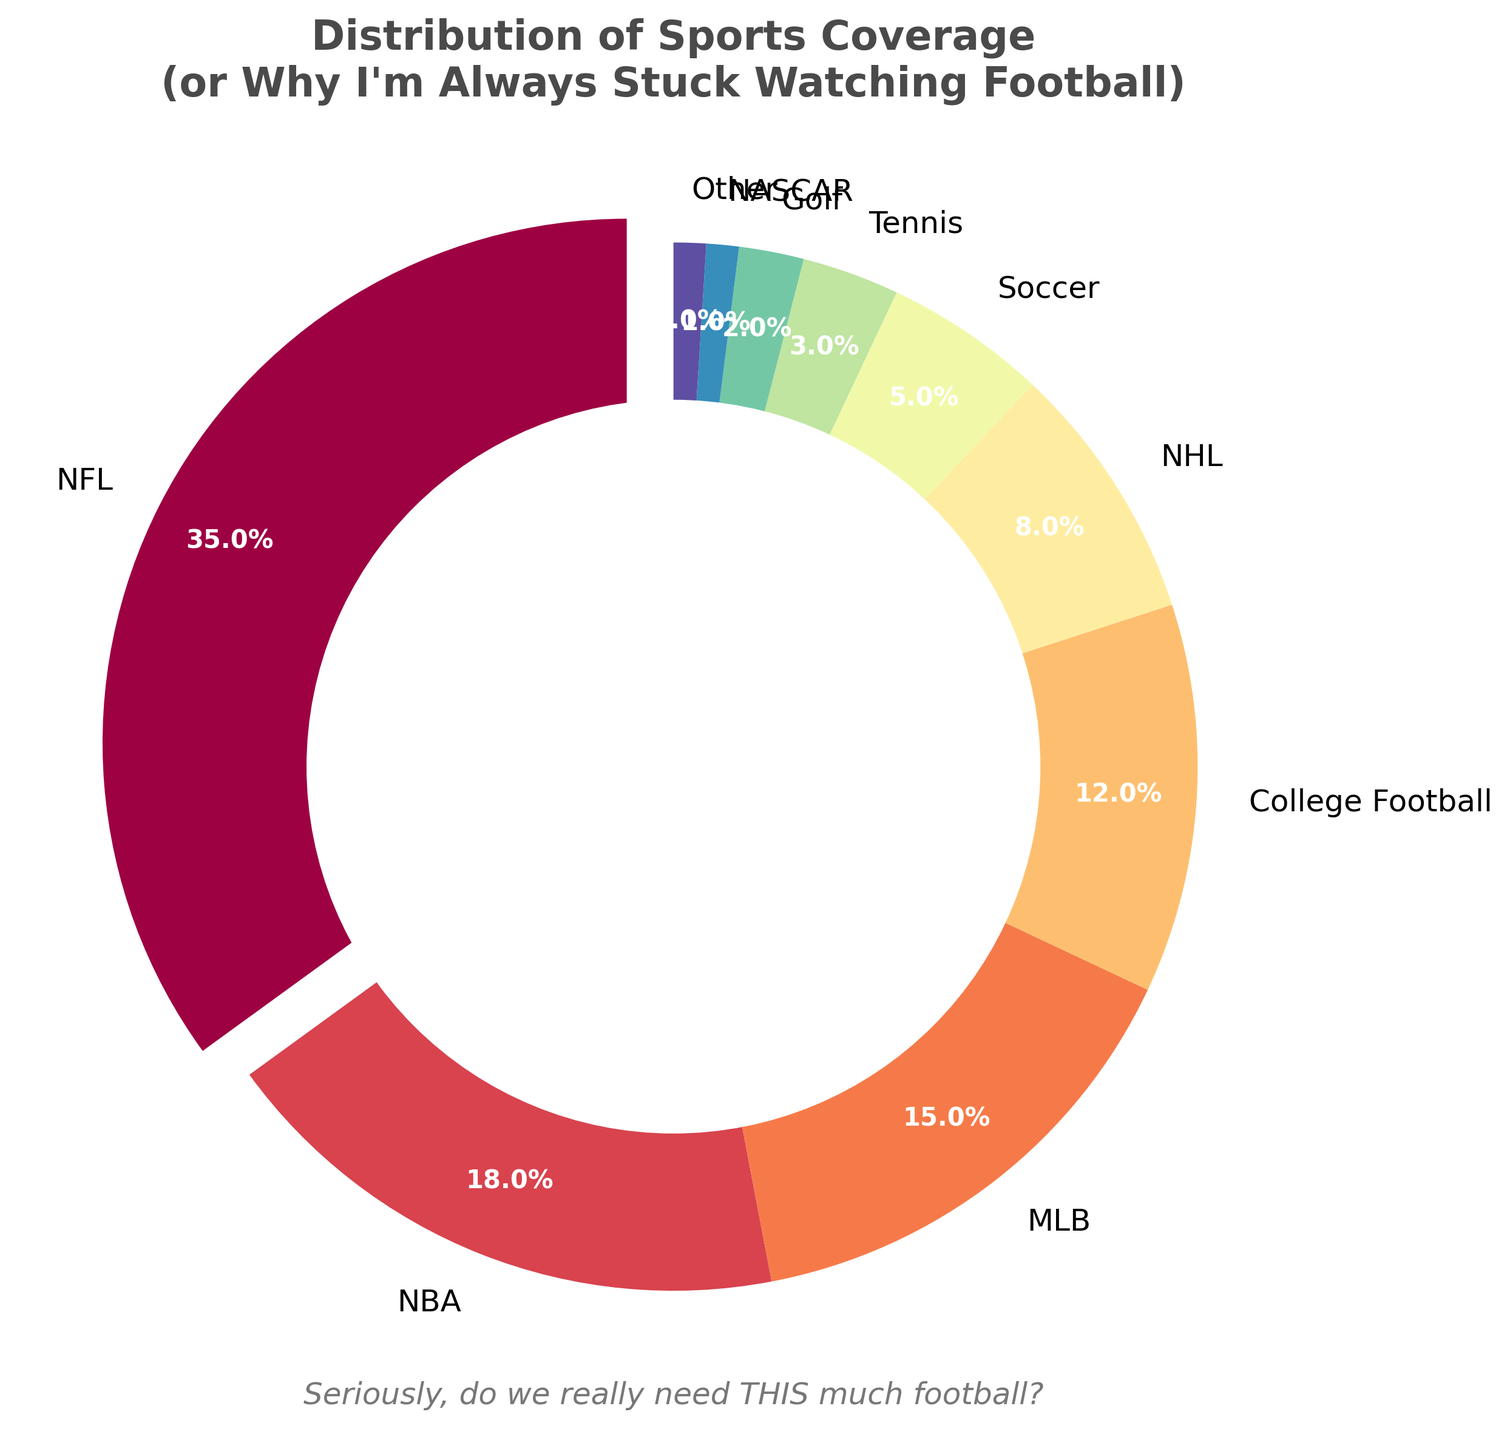what percentage of sports coverage is devoted to football (both NFL and College Football) combined? To find the combined percentage, add the coverage percentages of NFL and College Football. NFL is 35% and College Football is 12%, so 35% + 12% = 47%.
Answer: 47% Which sport has less coverage than Soccer but more than Golf? By examining the percentages, Soccer has 5% coverage, and Golf has 2%. Tennis falls between these values with 3% coverage.
Answer: Tennis How much more coverage does the NHL get compared to NASCAR? The NHL has 8% coverage, and NASCAR has 1%. The difference is 8% - 1% = 7%.
Answer: 7% What fraction of the pie chart is dedicated to NBA and MLB combined, and how does this compare to NFL coverage? NBA has 18% coverage, and MLB has 15%, so combined they are 18% + 15% = 33%, compared to NFL's 35%. So, NBA and MLB combined cover slightly less than NFL.
Answer: 33% Which sports combined together provide the remaining coverage outside of Football (NFL and College Football)? Football (NFL + College Football) is 47%, so the remaining coverage is 100% - 47% = 53%. Combining the other sports gives NBA (18%) + MLB (15%) + NHL (8%) + Soccer (5%) + Tennis (3%) + Golf (2%) + NASCAR (1%) + Other (1%) = 53%, confirming the correct total.
Answer: NBA, MLB, NHL, Soccer, Tennis, Golf, NASCAR, Other 